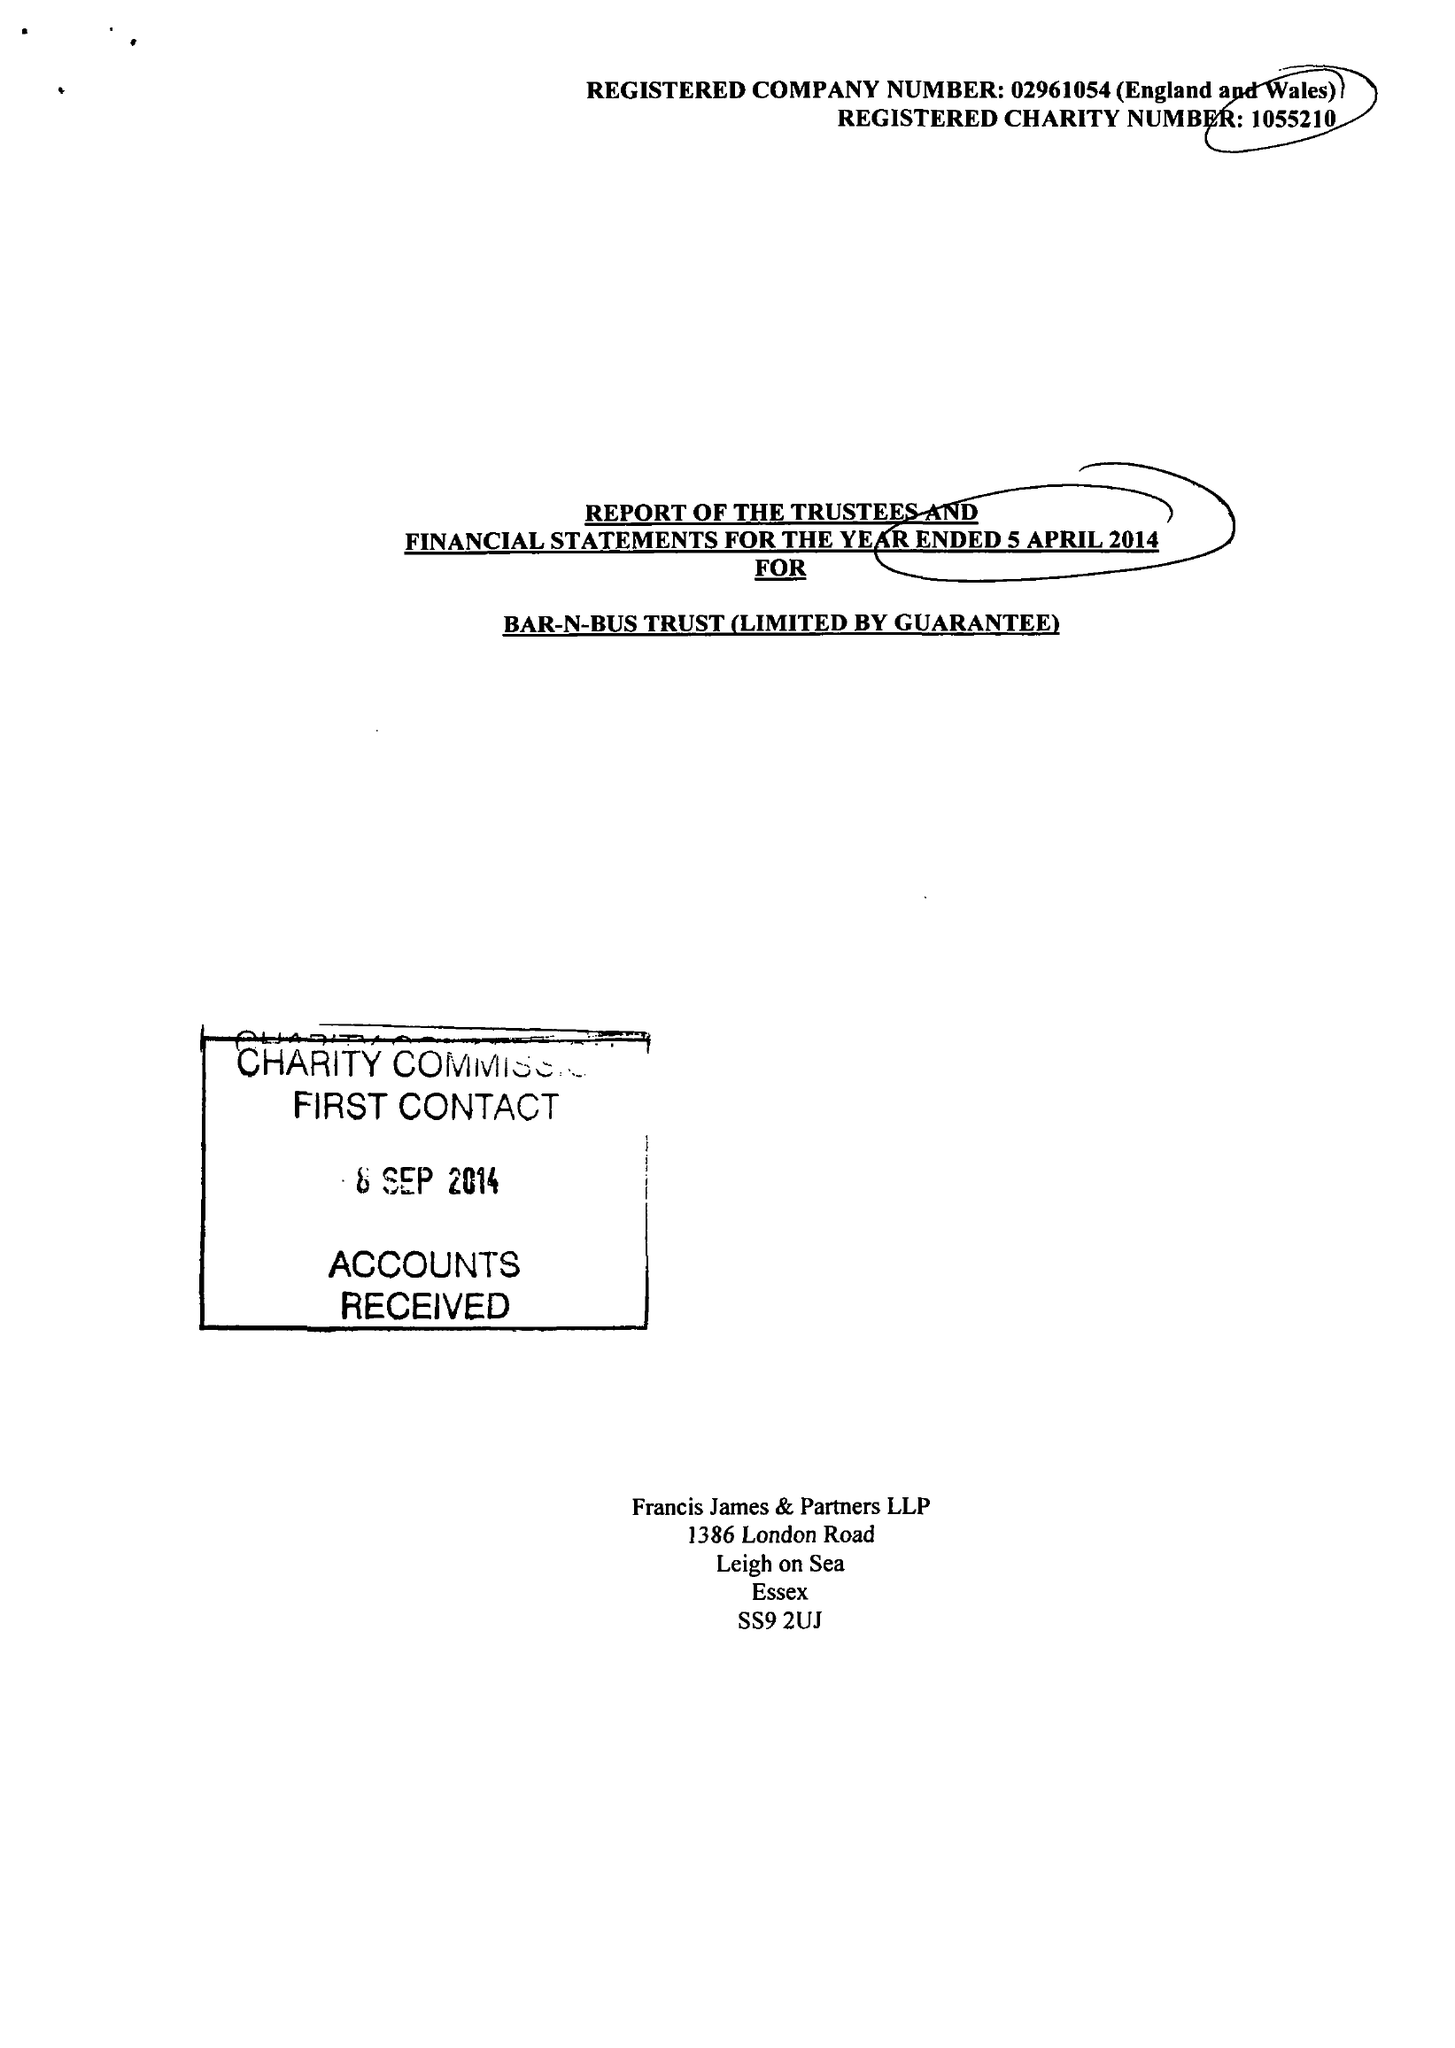What is the value for the address__postcode?
Answer the question using a single word or phrase. SS9 2UJ 